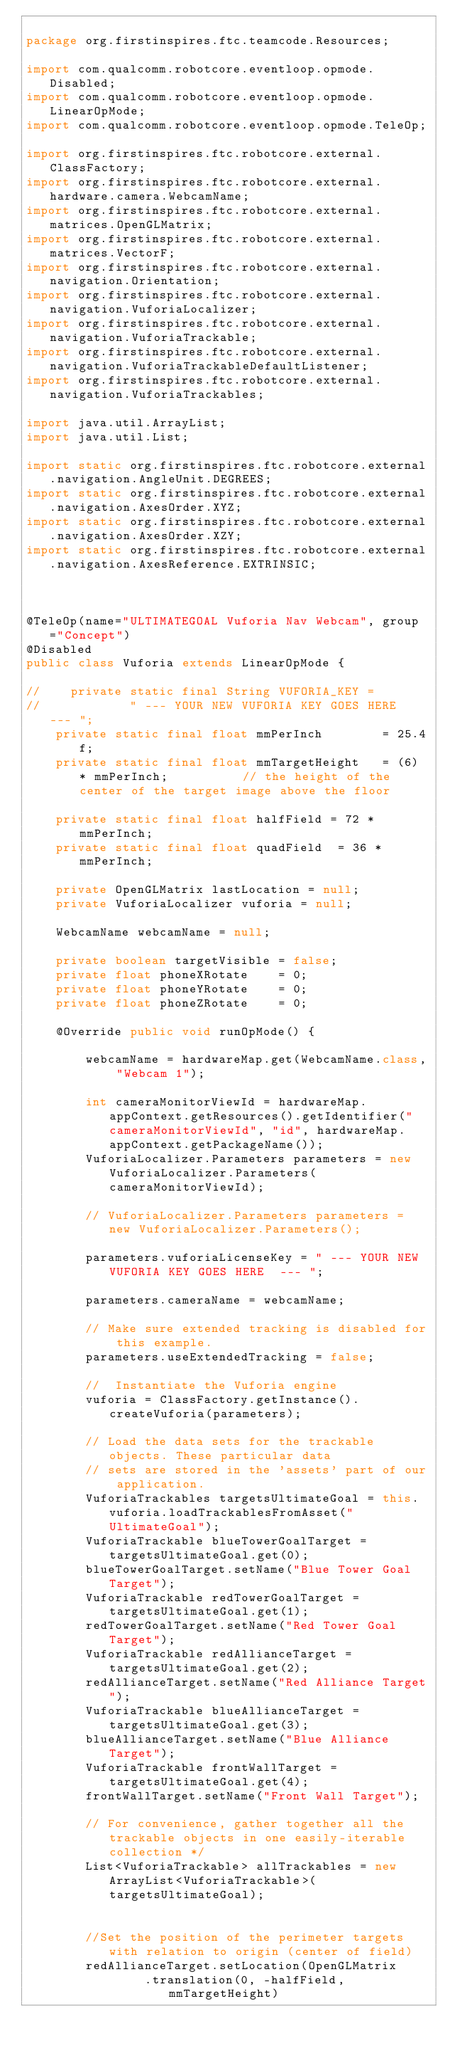Convert code to text. <code><loc_0><loc_0><loc_500><loc_500><_Java_>
package org.firstinspires.ftc.teamcode.Resources;

import com.qualcomm.robotcore.eventloop.opmode.Disabled;
import com.qualcomm.robotcore.eventloop.opmode.LinearOpMode;
import com.qualcomm.robotcore.eventloop.opmode.TeleOp;

import org.firstinspires.ftc.robotcore.external.ClassFactory;
import org.firstinspires.ftc.robotcore.external.hardware.camera.WebcamName;
import org.firstinspires.ftc.robotcore.external.matrices.OpenGLMatrix;
import org.firstinspires.ftc.robotcore.external.matrices.VectorF;
import org.firstinspires.ftc.robotcore.external.navigation.Orientation;
import org.firstinspires.ftc.robotcore.external.navigation.VuforiaLocalizer;
import org.firstinspires.ftc.robotcore.external.navigation.VuforiaTrackable;
import org.firstinspires.ftc.robotcore.external.navigation.VuforiaTrackableDefaultListener;
import org.firstinspires.ftc.robotcore.external.navigation.VuforiaTrackables;

import java.util.ArrayList;
import java.util.List;

import static org.firstinspires.ftc.robotcore.external.navigation.AngleUnit.DEGREES;
import static org.firstinspires.ftc.robotcore.external.navigation.AxesOrder.XYZ;
import static org.firstinspires.ftc.robotcore.external.navigation.AxesOrder.XZY;
import static org.firstinspires.ftc.robotcore.external.navigation.AxesReference.EXTRINSIC;



@TeleOp(name="ULTIMATEGOAL Vuforia Nav Webcam", group ="Concept")
@Disabled
public class Vuforia extends LinearOpMode {

//    private static final String VUFORIA_KEY =
//            " --- YOUR NEW VUFORIA KEY GOES HERE  --- ";
    private static final float mmPerInch        = 25.4f;
    private static final float mmTargetHeight   = (6) * mmPerInch;          // the height of the center of the target image above the floor

    private static final float halfField = 72 * mmPerInch;
    private static final float quadField  = 36 * mmPerInch;

    private OpenGLMatrix lastLocation = null;
    private VuforiaLocalizer vuforia = null;

    WebcamName webcamName = null;

    private boolean targetVisible = false;
    private float phoneXRotate    = 0;
    private float phoneYRotate    = 0;
    private float phoneZRotate    = 0;

    @Override public void runOpMode() {

        webcamName = hardwareMap.get(WebcamName.class, "Webcam 1");

        int cameraMonitorViewId = hardwareMap.appContext.getResources().getIdentifier("cameraMonitorViewId", "id", hardwareMap.appContext.getPackageName());
        VuforiaLocalizer.Parameters parameters = new VuforiaLocalizer.Parameters(cameraMonitorViewId);

        // VuforiaLocalizer.Parameters parameters = new VuforiaLocalizer.Parameters();

        parameters.vuforiaLicenseKey = " --- YOUR NEW VUFORIA KEY GOES HERE  --- ";

        parameters.cameraName = webcamName;

        // Make sure extended tracking is disabled for this example.
        parameters.useExtendedTracking = false;

        //  Instantiate the Vuforia engine
        vuforia = ClassFactory.getInstance().createVuforia(parameters);

        // Load the data sets for the trackable objects. These particular data
        // sets are stored in the 'assets' part of our application.
        VuforiaTrackables targetsUltimateGoal = this.vuforia.loadTrackablesFromAsset("UltimateGoal");
        VuforiaTrackable blueTowerGoalTarget = targetsUltimateGoal.get(0);
        blueTowerGoalTarget.setName("Blue Tower Goal Target");
        VuforiaTrackable redTowerGoalTarget = targetsUltimateGoal.get(1);
        redTowerGoalTarget.setName("Red Tower Goal Target");
        VuforiaTrackable redAllianceTarget = targetsUltimateGoal.get(2);
        redAllianceTarget.setName("Red Alliance Target");
        VuforiaTrackable blueAllianceTarget = targetsUltimateGoal.get(3);
        blueAllianceTarget.setName("Blue Alliance Target");
        VuforiaTrackable frontWallTarget = targetsUltimateGoal.get(4);
        frontWallTarget.setName("Front Wall Target");

        // For convenience, gather together all the trackable objects in one easily-iterable collection */
        List<VuforiaTrackable> allTrackables = new ArrayList<VuforiaTrackable>(targetsUltimateGoal);


        //Set the position of the perimeter targets with relation to origin (center of field)
        redAllianceTarget.setLocation(OpenGLMatrix
                .translation(0, -halfField, mmTargetHeight)</code> 